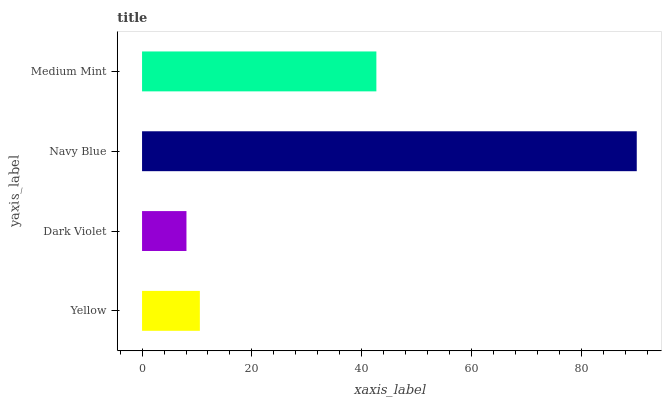Is Dark Violet the minimum?
Answer yes or no. Yes. Is Navy Blue the maximum?
Answer yes or no. Yes. Is Navy Blue the minimum?
Answer yes or no. No. Is Dark Violet the maximum?
Answer yes or no. No. Is Navy Blue greater than Dark Violet?
Answer yes or no. Yes. Is Dark Violet less than Navy Blue?
Answer yes or no. Yes. Is Dark Violet greater than Navy Blue?
Answer yes or no. No. Is Navy Blue less than Dark Violet?
Answer yes or no. No. Is Medium Mint the high median?
Answer yes or no. Yes. Is Yellow the low median?
Answer yes or no. Yes. Is Dark Violet the high median?
Answer yes or no. No. Is Medium Mint the low median?
Answer yes or no. No. 